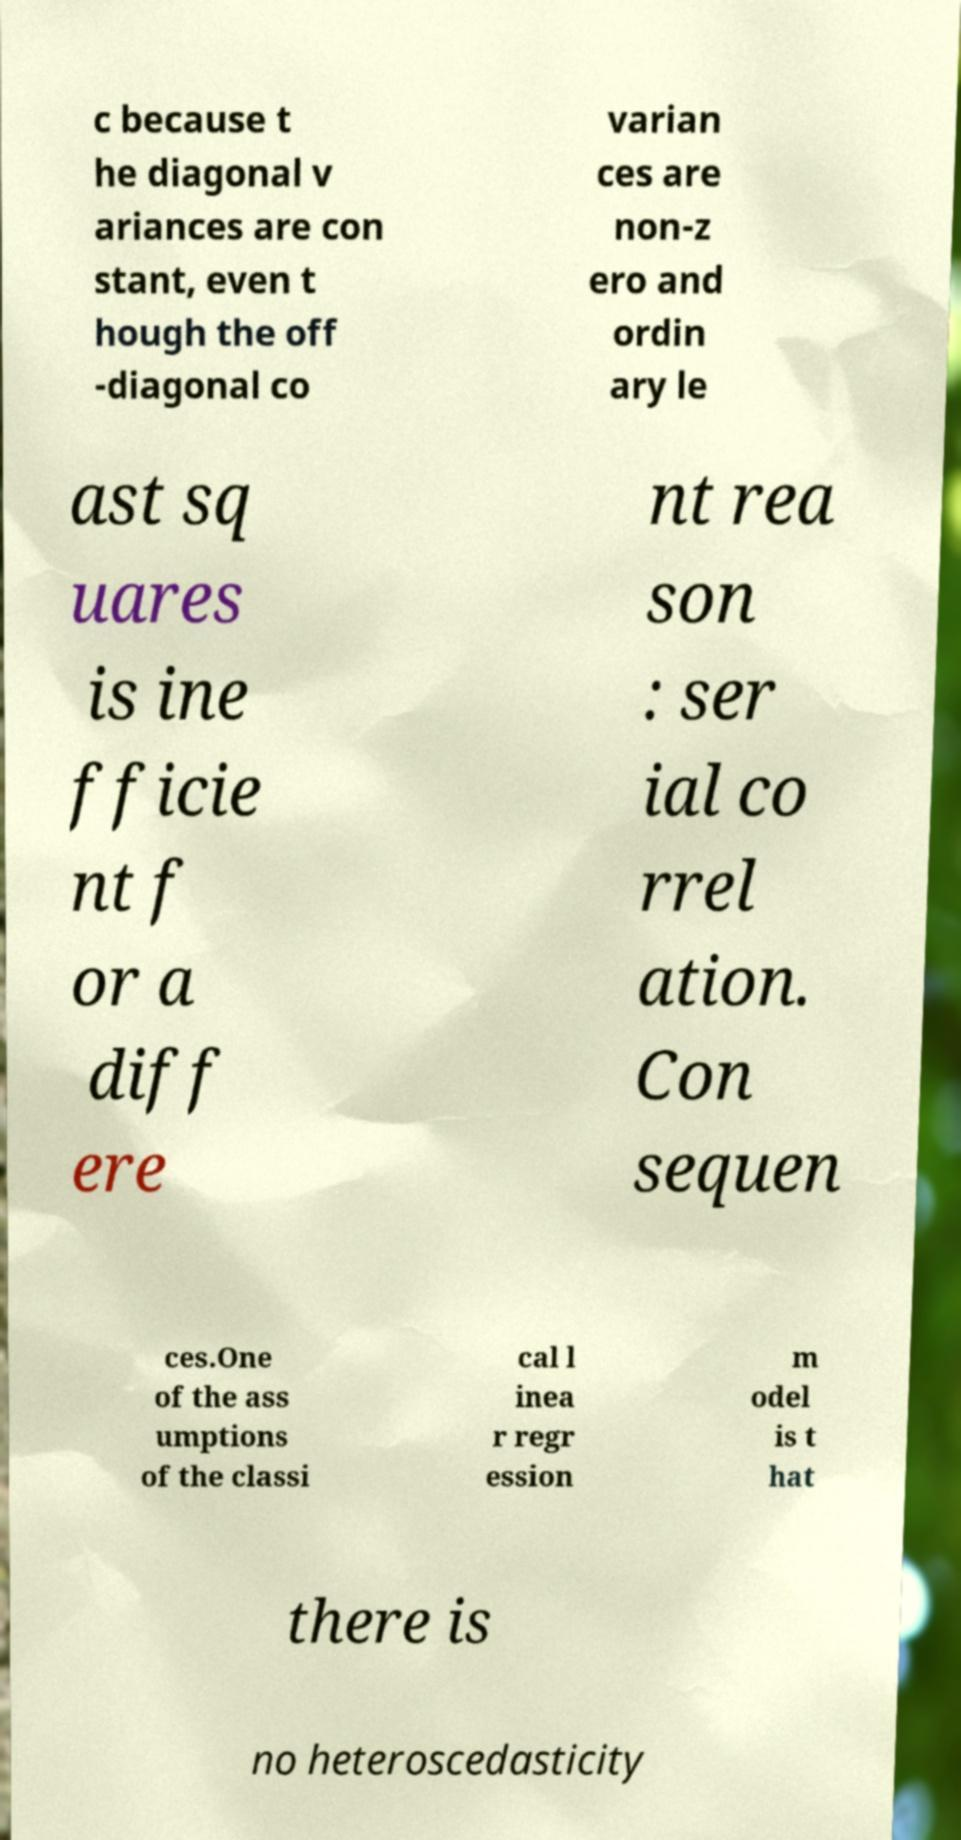Please identify and transcribe the text found in this image. c because t he diagonal v ariances are con stant, even t hough the off -diagonal co varian ces are non-z ero and ordin ary le ast sq uares is ine fficie nt f or a diff ere nt rea son : ser ial co rrel ation. Con sequen ces.One of the ass umptions of the classi cal l inea r regr ession m odel is t hat there is no heteroscedasticity 